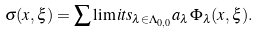Convert formula to latex. <formula><loc_0><loc_0><loc_500><loc_500>\sigma ( x , \xi ) = \sum \lim i t s _ { \lambda \in \Lambda _ { 0 , 0 } } a _ { \lambda } \Phi _ { \lambda } ( x , \xi ) .</formula> 